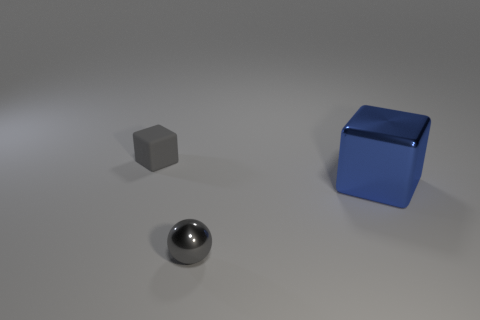Add 1 tiny gray rubber objects. How many objects exist? 4 Subtract all spheres. How many objects are left? 2 Add 3 big cyan rubber cylinders. How many big cyan rubber cylinders exist? 3 Subtract 1 gray balls. How many objects are left? 2 Subtract all brown rubber objects. Subtract all gray objects. How many objects are left? 1 Add 3 gray matte blocks. How many gray matte blocks are left? 4 